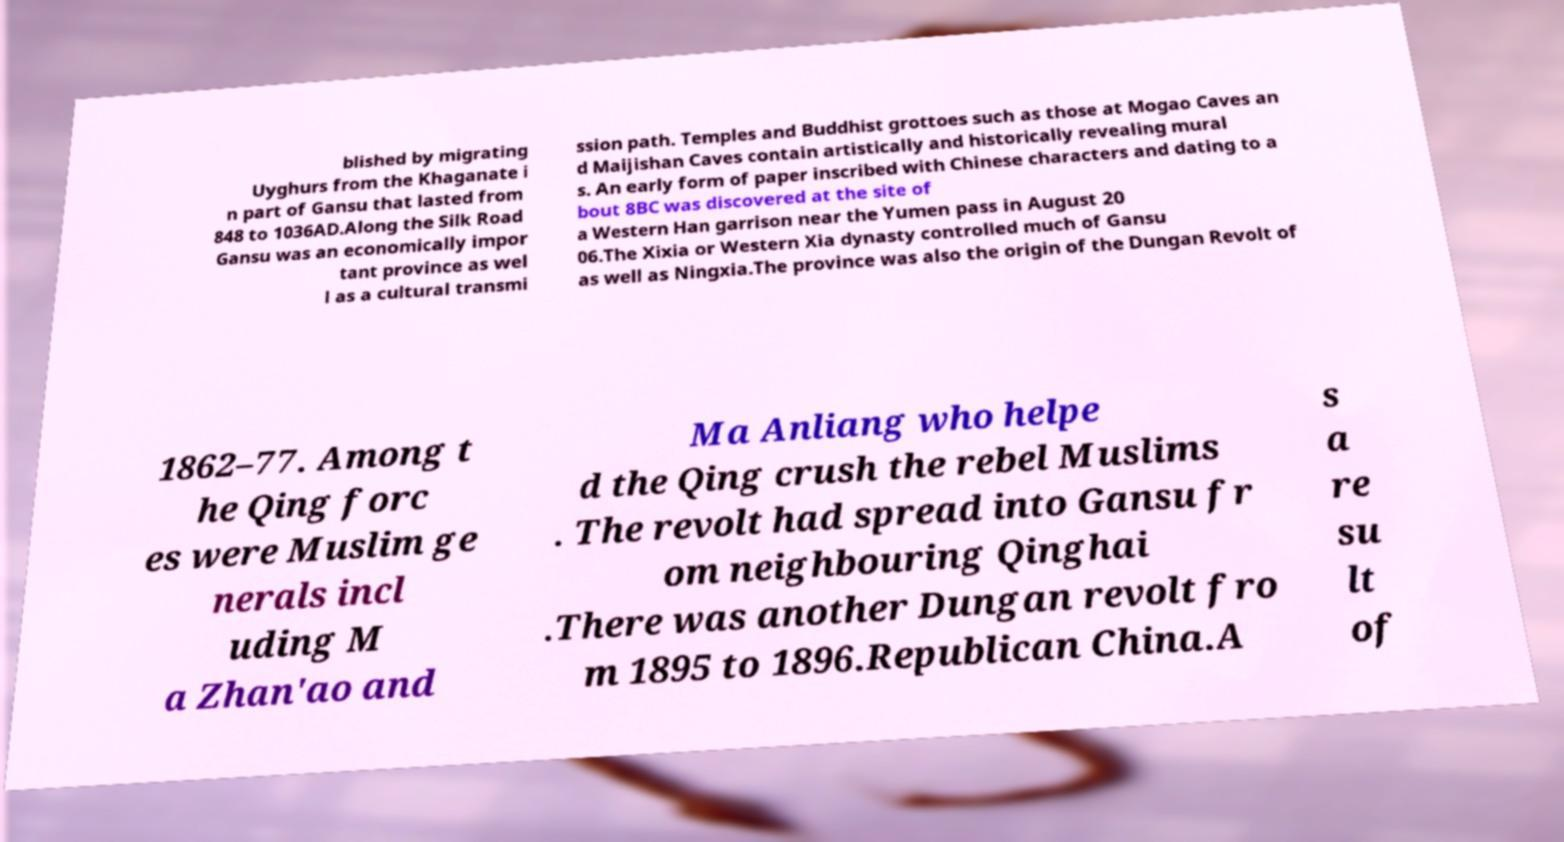I need the written content from this picture converted into text. Can you do that? blished by migrating Uyghurs from the Khaganate i n part of Gansu that lasted from 848 to 1036AD.Along the Silk Road Gansu was an economically impor tant province as wel l as a cultural transmi ssion path. Temples and Buddhist grottoes such as those at Mogao Caves an d Maijishan Caves contain artistically and historically revealing mural s. An early form of paper inscribed with Chinese characters and dating to a bout 8BC was discovered at the site of a Western Han garrison near the Yumen pass in August 20 06.The Xixia or Western Xia dynasty controlled much of Gansu as well as Ningxia.The province was also the origin of the Dungan Revolt of 1862–77. Among t he Qing forc es were Muslim ge nerals incl uding M a Zhan'ao and Ma Anliang who helpe d the Qing crush the rebel Muslims . The revolt had spread into Gansu fr om neighbouring Qinghai .There was another Dungan revolt fro m 1895 to 1896.Republican China.A s a re su lt of 